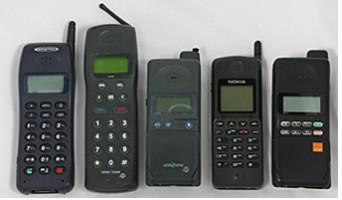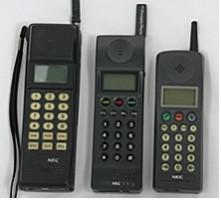The first image is the image on the left, the second image is the image on the right. For the images shown, is this caption "In each image, three or more cellphones with keypads and antenna knobs are shown upright and side by side." true? Answer yes or no. Yes. The first image is the image on the left, the second image is the image on the right. Evaluate the accuracy of this statement regarding the images: "There are three black phones in a row with small antennas on the right side.". Is it true? Answer yes or no. Yes. 